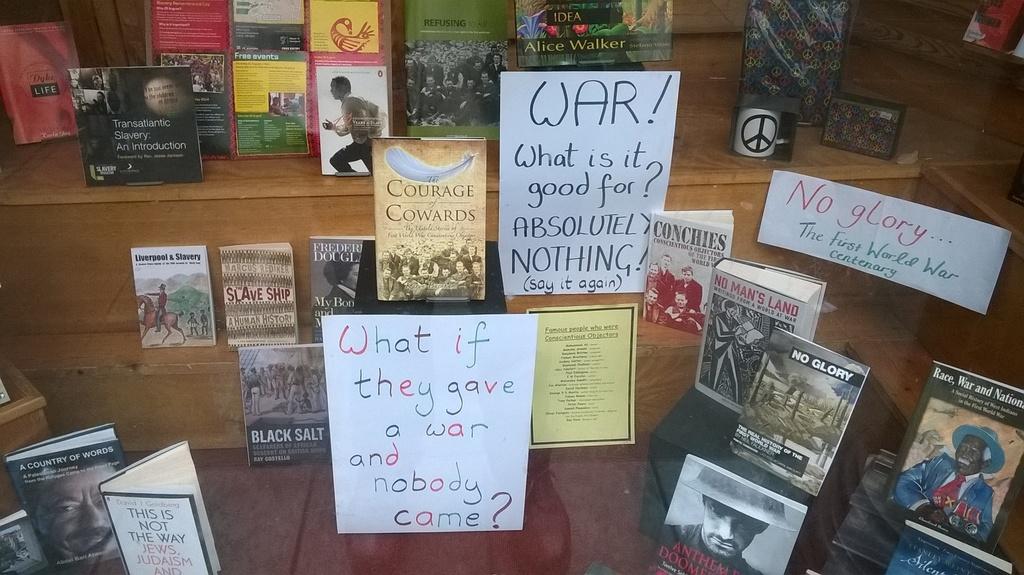Fill in the blank war what is it   for?
Offer a very short reply. Absolutely nothing. 